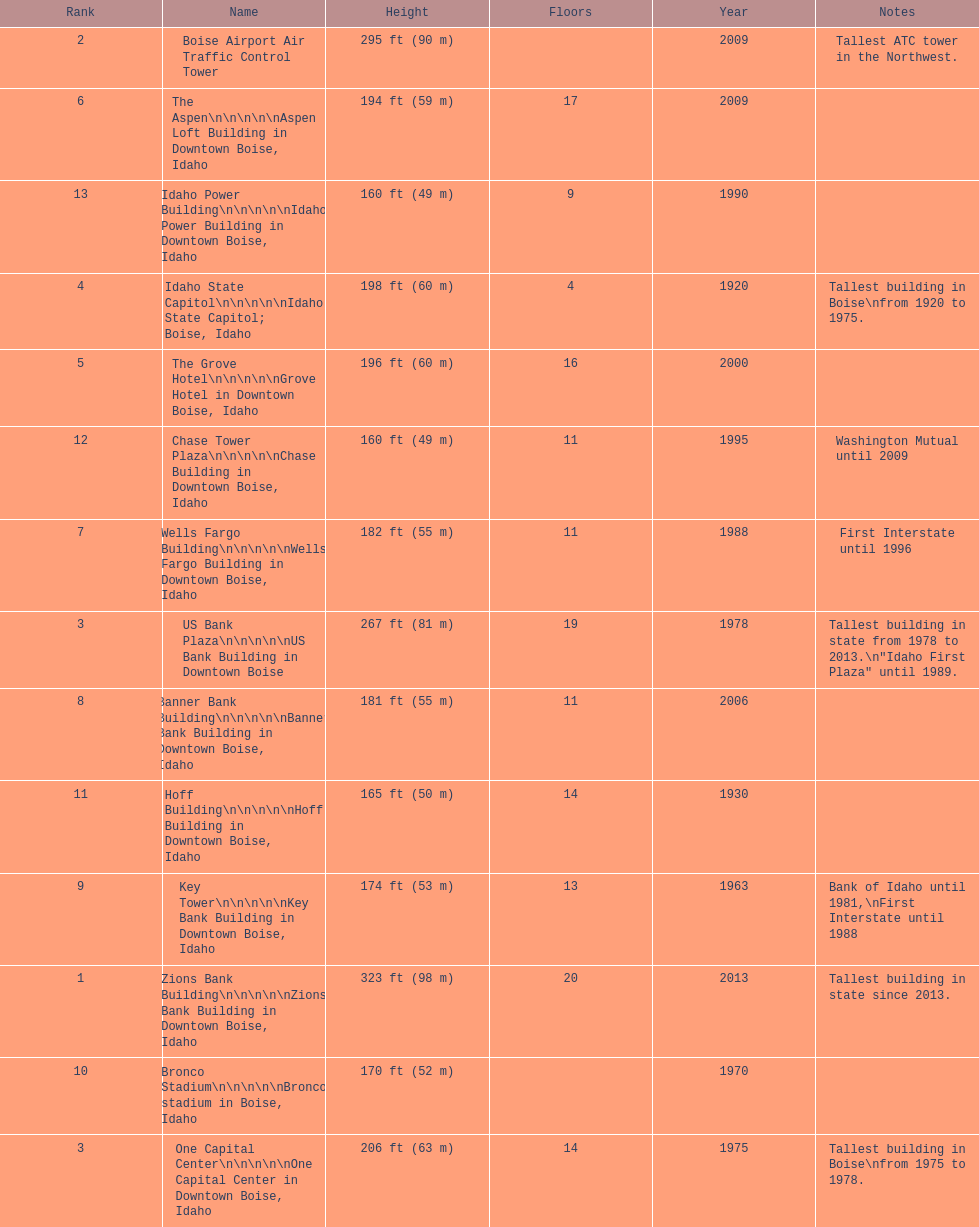Which building has the most floors according to this chart? Zions Bank Building. 